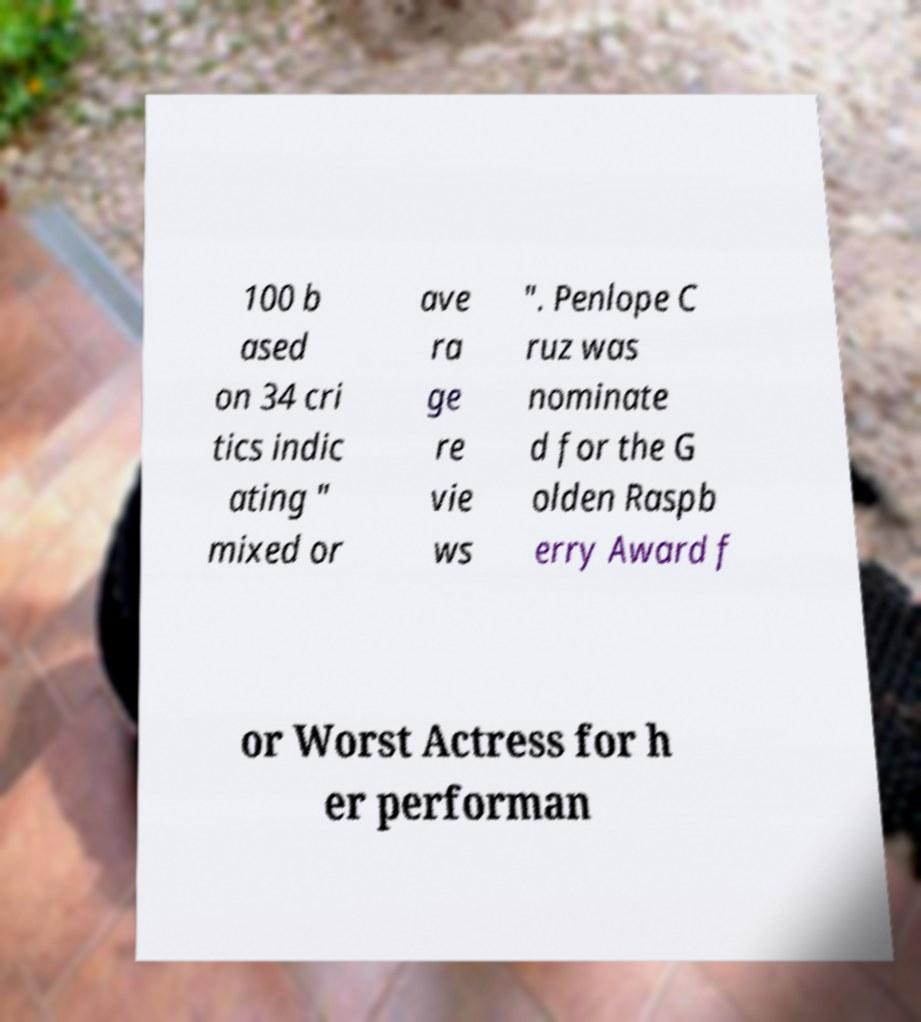Can you read and provide the text displayed in the image?This photo seems to have some interesting text. Can you extract and type it out for me? 100 b ased on 34 cri tics indic ating " mixed or ave ra ge re vie ws ". Penlope C ruz was nominate d for the G olden Raspb erry Award f or Worst Actress for h er performan 